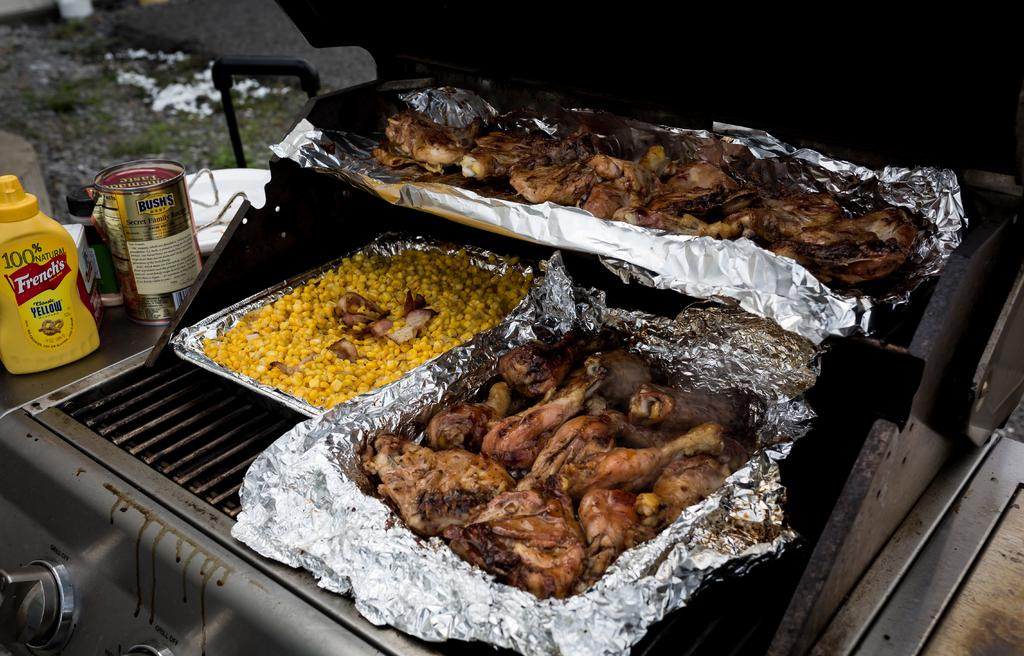Provide a one-sentence caption for the provided image. barbecue chicken and corn on a grill with French's mustard on the grill sideboard. 